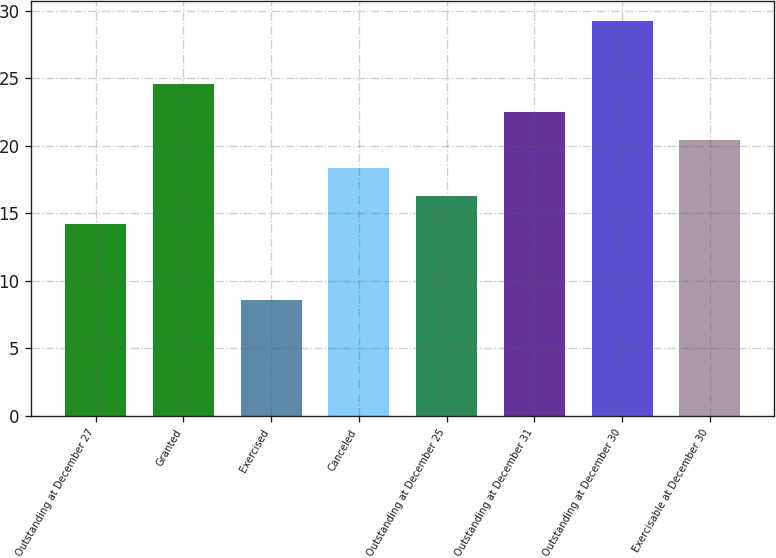Convert chart to OTSL. <chart><loc_0><loc_0><loc_500><loc_500><bar_chart><fcel>Outstanding at December 27<fcel>Granted<fcel>Exercised<fcel>Canceled<fcel>Outstanding at December 25<fcel>Outstanding at December 31<fcel>Outstanding at December 30<fcel>Exercisable at December 30<nl><fcel>14.21<fcel>24.56<fcel>8.56<fcel>18.35<fcel>16.28<fcel>22.49<fcel>29.24<fcel>20.42<nl></chart> 